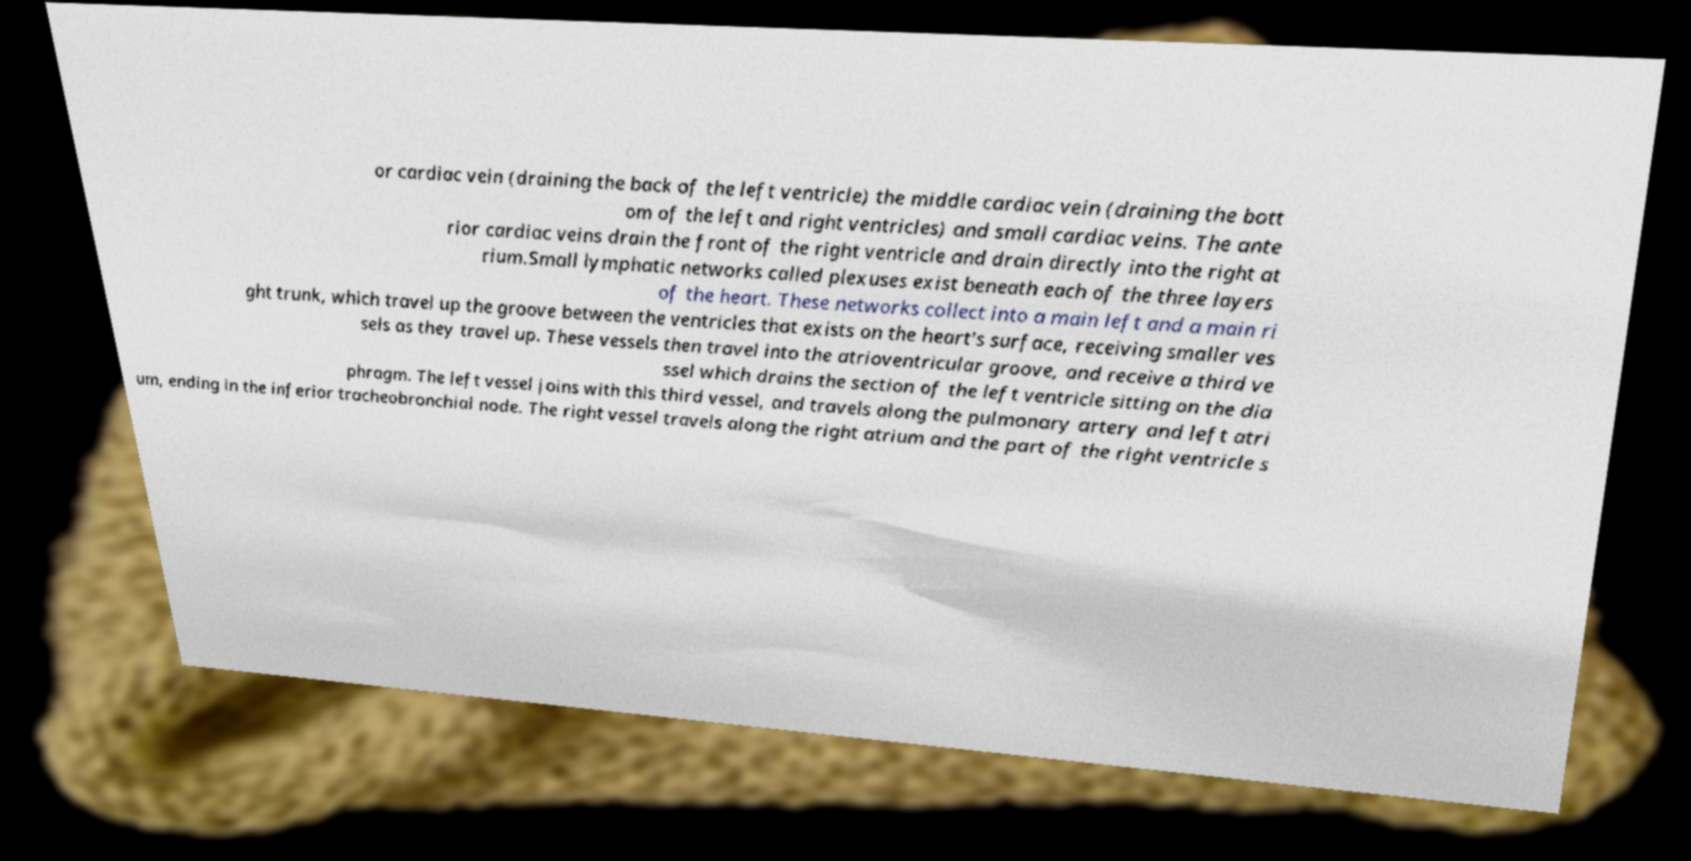Can you accurately transcribe the text from the provided image for me? or cardiac vein (draining the back of the left ventricle) the middle cardiac vein (draining the bott om of the left and right ventricles) and small cardiac veins. The ante rior cardiac veins drain the front of the right ventricle and drain directly into the right at rium.Small lymphatic networks called plexuses exist beneath each of the three layers of the heart. These networks collect into a main left and a main ri ght trunk, which travel up the groove between the ventricles that exists on the heart's surface, receiving smaller ves sels as they travel up. These vessels then travel into the atrioventricular groove, and receive a third ve ssel which drains the section of the left ventricle sitting on the dia phragm. The left vessel joins with this third vessel, and travels along the pulmonary artery and left atri um, ending in the inferior tracheobronchial node. The right vessel travels along the right atrium and the part of the right ventricle s 